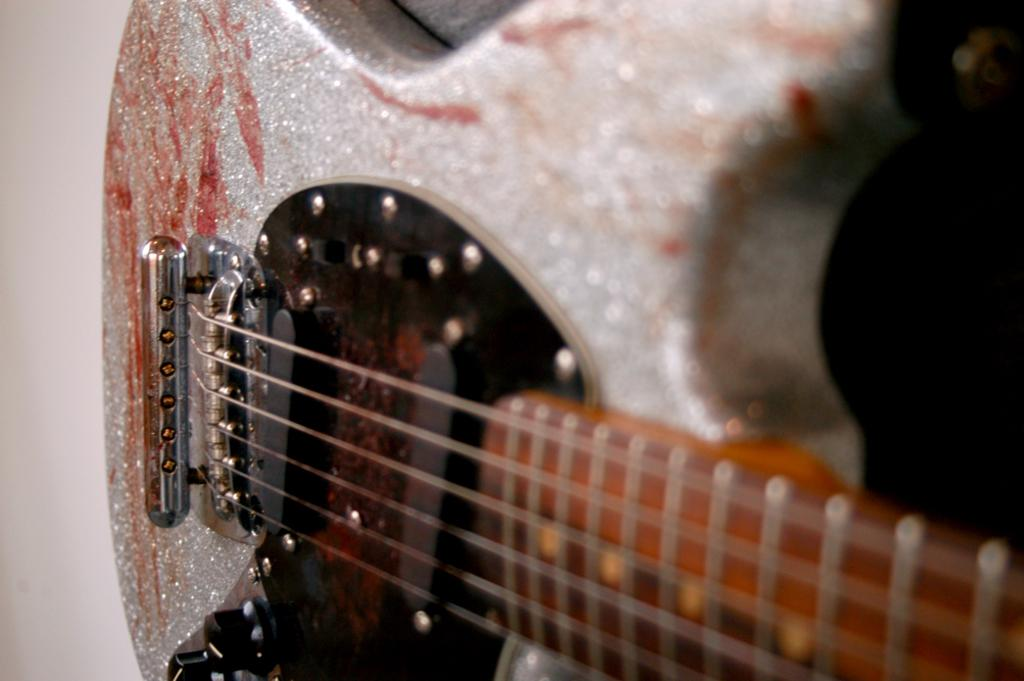What musical instrument is present in the image? There is a guitar in the image. What type of strings does the guitar have? The facts provided do not specify the type of strings on the guitar. How many mice can be seen running around the guitar in the image? There are no mice present in the image; it only features a guitar. 